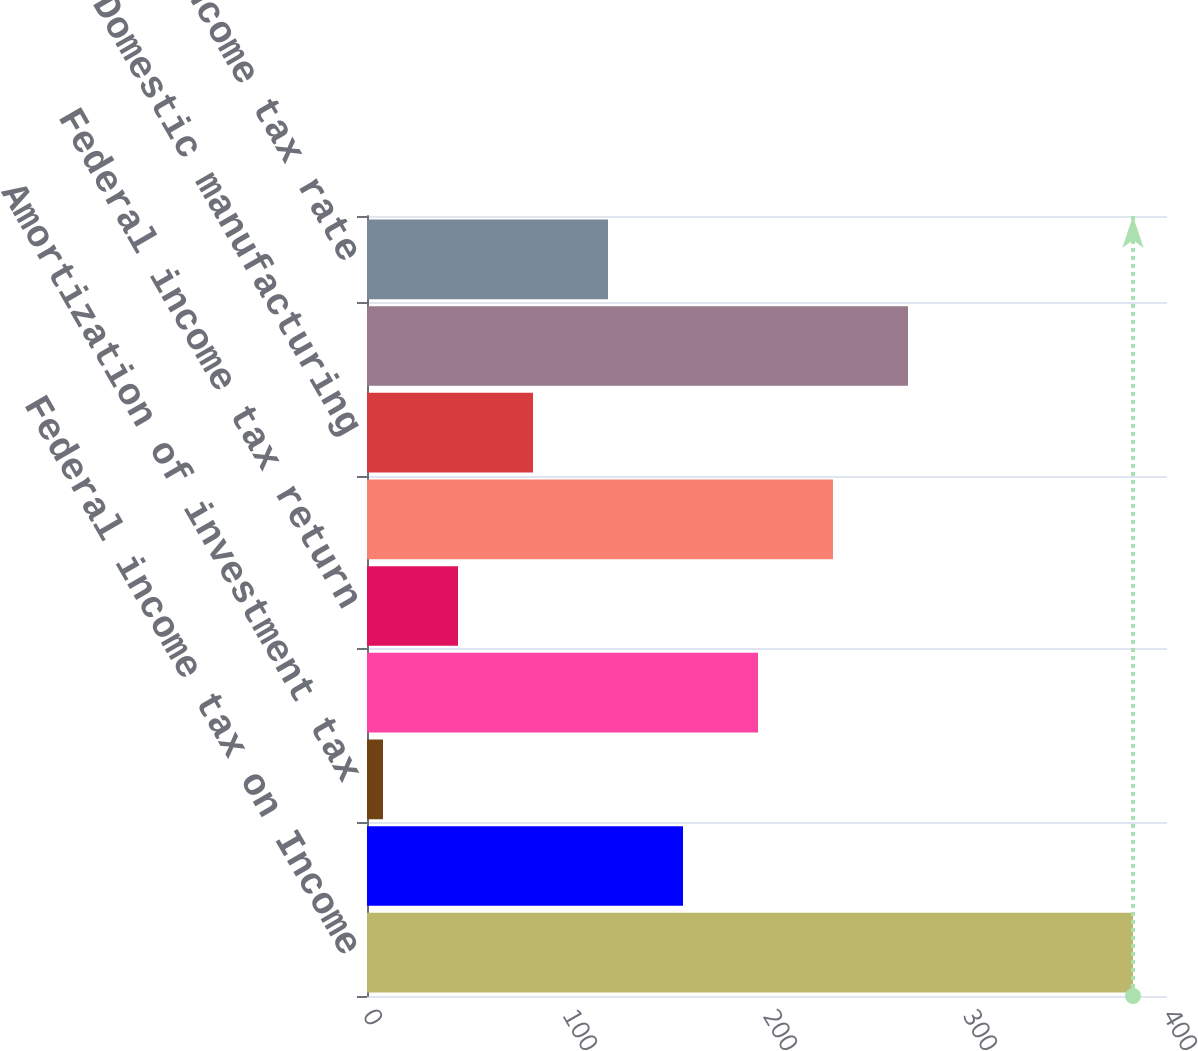Convert chart to OTSL. <chart><loc_0><loc_0><loc_500><loc_500><bar_chart><fcel>Federal income tax on Income<fcel>State income taxes (a) (b)<fcel>Amortization of investment tax<fcel>Difference related to income<fcel>Federal income tax return<fcel>Federal income tax credits (b)<fcel>Domestic manufacturing<fcel>Total income tax expense<fcel>Effective income tax rate<nl><fcel>383<fcel>158<fcel>8<fcel>195.5<fcel>45.5<fcel>233<fcel>83<fcel>270.5<fcel>120.5<nl></chart> 